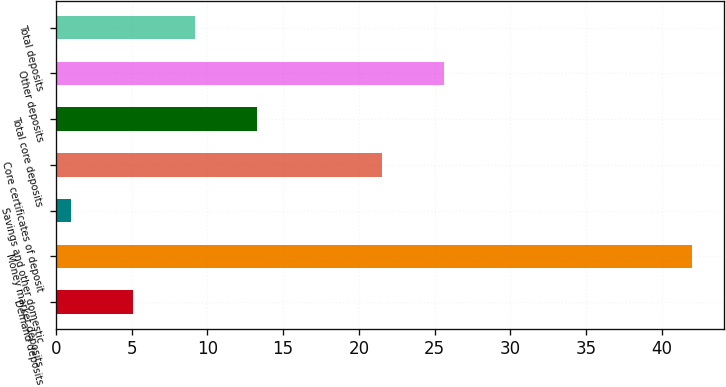<chart> <loc_0><loc_0><loc_500><loc_500><bar_chart><fcel>Demand deposits<fcel>Money market deposits<fcel>Savings and other domestic<fcel>Core certificates of deposit<fcel>Total core deposits<fcel>Other deposits<fcel>Total deposits<nl><fcel>5.1<fcel>42<fcel>1<fcel>21.5<fcel>13.3<fcel>25.6<fcel>9.2<nl></chart> 